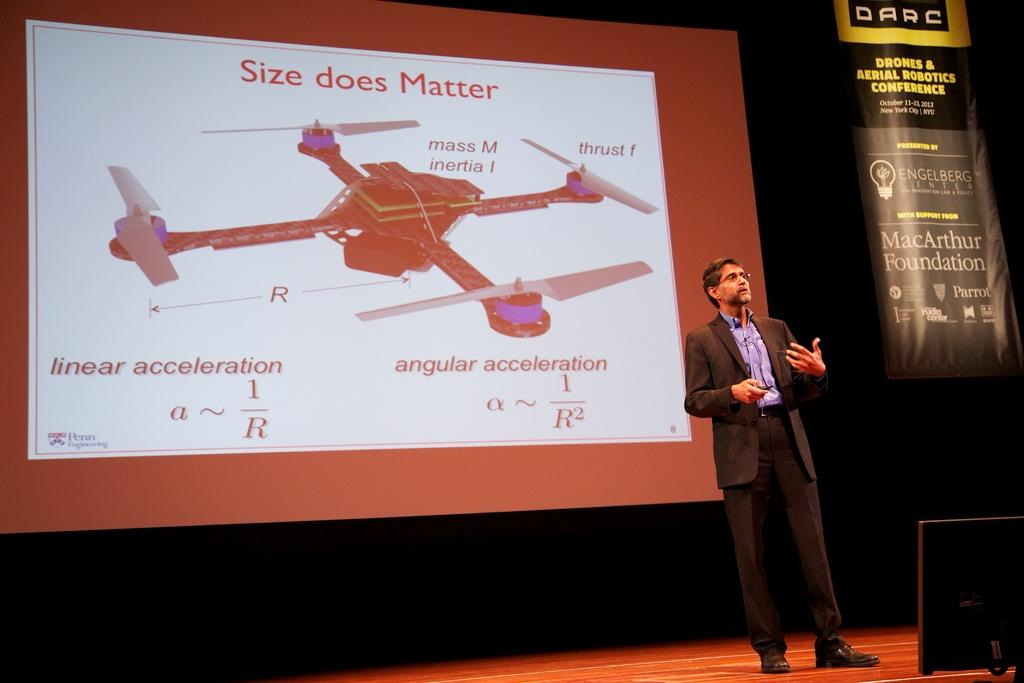<image>
Present a compact description of the photo's key features. A man in a suit presenting a drone that says does matter. 